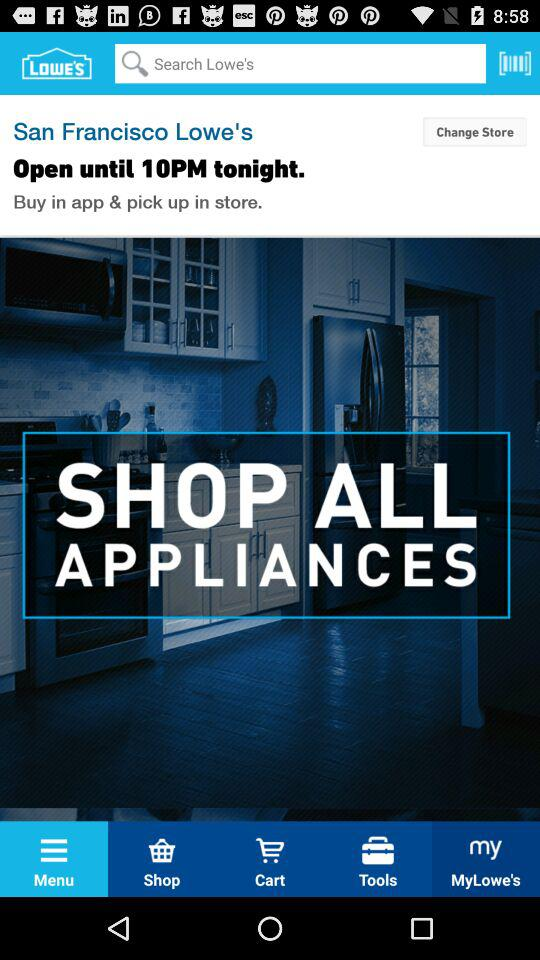What is the name of the application? The name of the application is "Lowe's". 